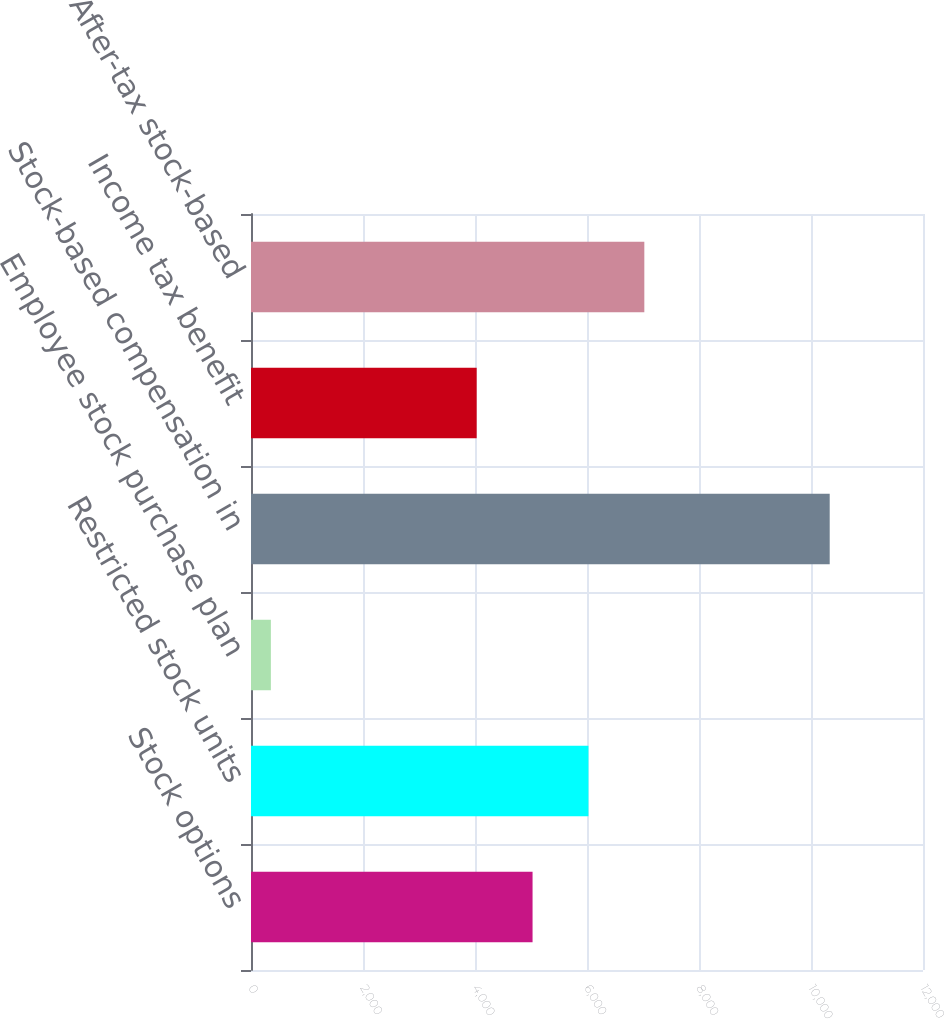Convert chart to OTSL. <chart><loc_0><loc_0><loc_500><loc_500><bar_chart><fcel>Stock options<fcel>Restricted stock units<fcel>Employee stock purchase plan<fcel>Stock-based compensation in<fcel>Income tax benefit<fcel>After-tax stock-based<nl><fcel>5027.9<fcel>6025.8<fcel>355<fcel>10334<fcel>4030<fcel>7023.7<nl></chart> 